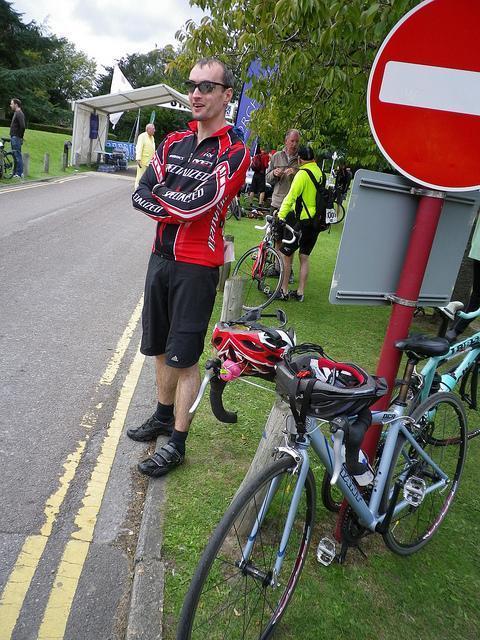How many bicycles are there?
Give a very brief answer. 3. How many stop signs are there?
Give a very brief answer. 1. How many people are there?
Give a very brief answer. 2. 